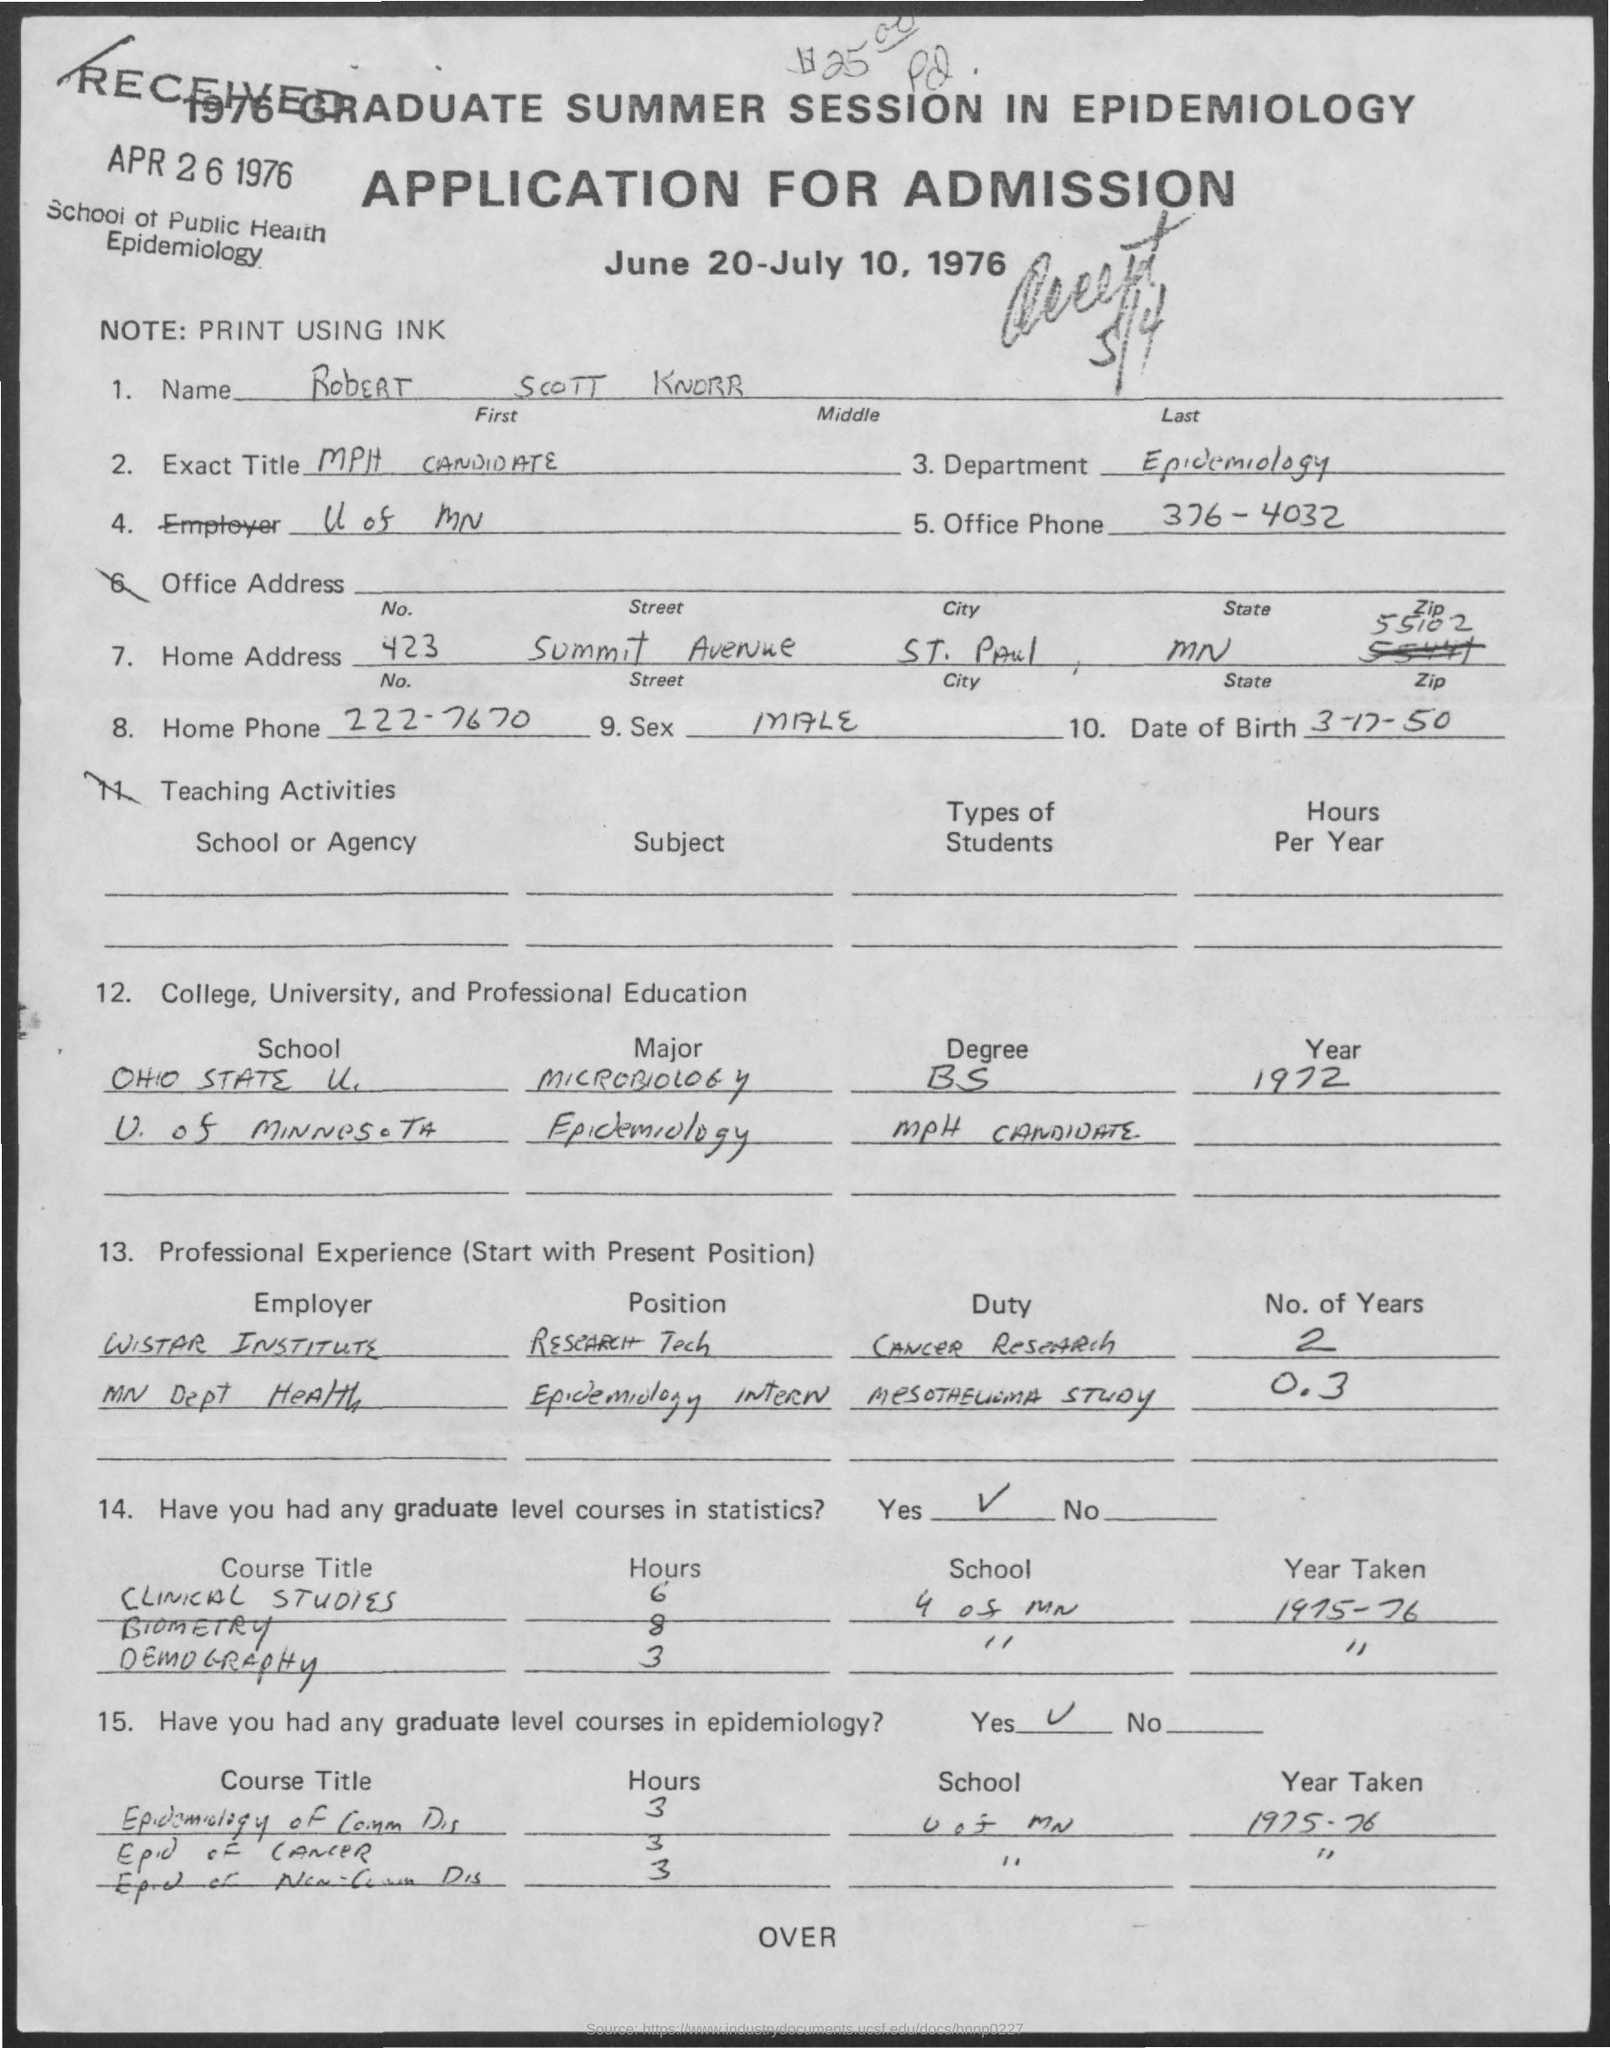What is the name of the person in the application?
Your answer should be compact. RObERT SCOTT KNORR. Which department is mentioned in this application?
Ensure brevity in your answer.  Epidemiology. What is the Exact Title of Robert Scott Knorr as given in the application?
Ensure brevity in your answer.  MPH CANDIDATE. What is the Office Phone no mentioned in the application?
Provide a short and direct response. 376-4032. What is the Date of Birth of Robert Scott Knorr?
Your answer should be very brief. 3-17-50. What is the zipcode mentioned in the application?
Keep it short and to the point. 55102. In which year, Robert Scott Knorr completed B. S. in Microbiology?
Your answer should be compact. 1972. What was the duty assigned to Robert Scott Knorr as a Research Tech in Wistar Institute?
Make the answer very short. CANCER RESEARCH. 